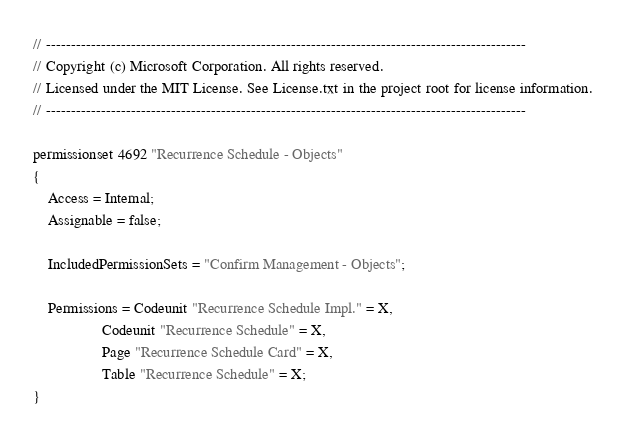<code> <loc_0><loc_0><loc_500><loc_500><_Perl_>// ------------------------------------------------------------------------------------------------
// Copyright (c) Microsoft Corporation. All rights reserved.
// Licensed under the MIT License. See License.txt in the project root for license information.
// ------------------------------------------------------------------------------------------------

permissionset 4692 "Recurrence Schedule - Objects"
{
    Access = Internal;
    Assignable = false;

    IncludedPermissionSets = "Confirm Management - Objects";

    Permissions = Codeunit "Recurrence Schedule Impl." = X,
                  Codeunit "Recurrence Schedule" = X,
                  Page "Recurrence Schedule Card" = X,
                  Table "Recurrence Schedule" = X;
}
</code> 